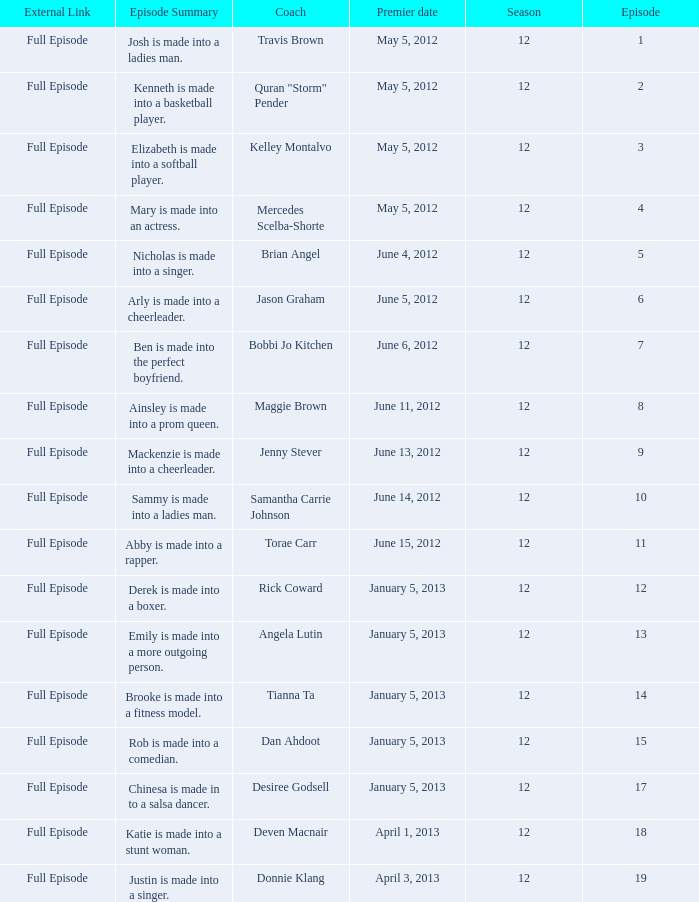Name the episode summary for torae carr Abby is made into a rapper. 